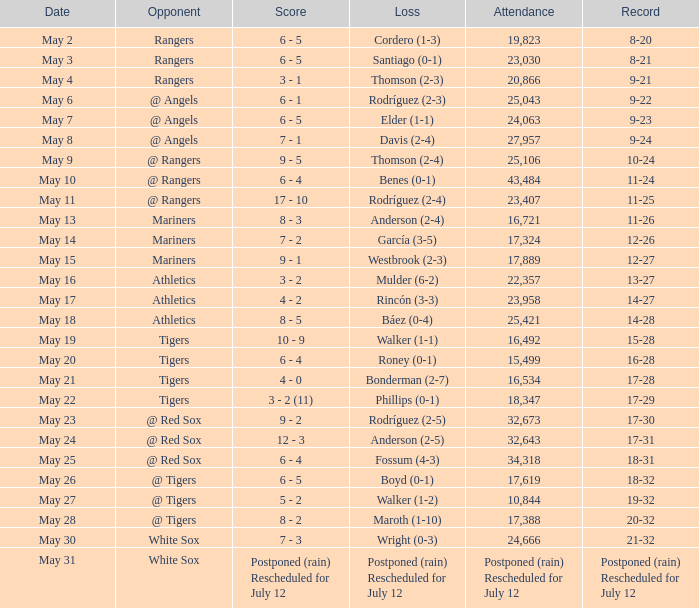What date did the Indians have a record of 14-28? May 18. 